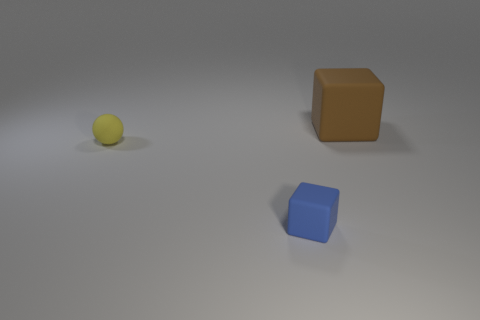Add 1 big things. How many objects exist? 4 Subtract 1 balls. How many balls are left? 0 Subtract all blocks. How many objects are left? 1 Add 2 yellow blocks. How many yellow blocks exist? 2 Subtract all brown cubes. How many cubes are left? 1 Subtract 0 cyan cubes. How many objects are left? 3 Subtract all gray cubes. Subtract all gray spheres. How many cubes are left? 2 Subtract all green balls. How many brown blocks are left? 1 Subtract all small yellow matte objects. Subtract all small cyan objects. How many objects are left? 2 Add 2 yellow matte objects. How many yellow matte objects are left? 3 